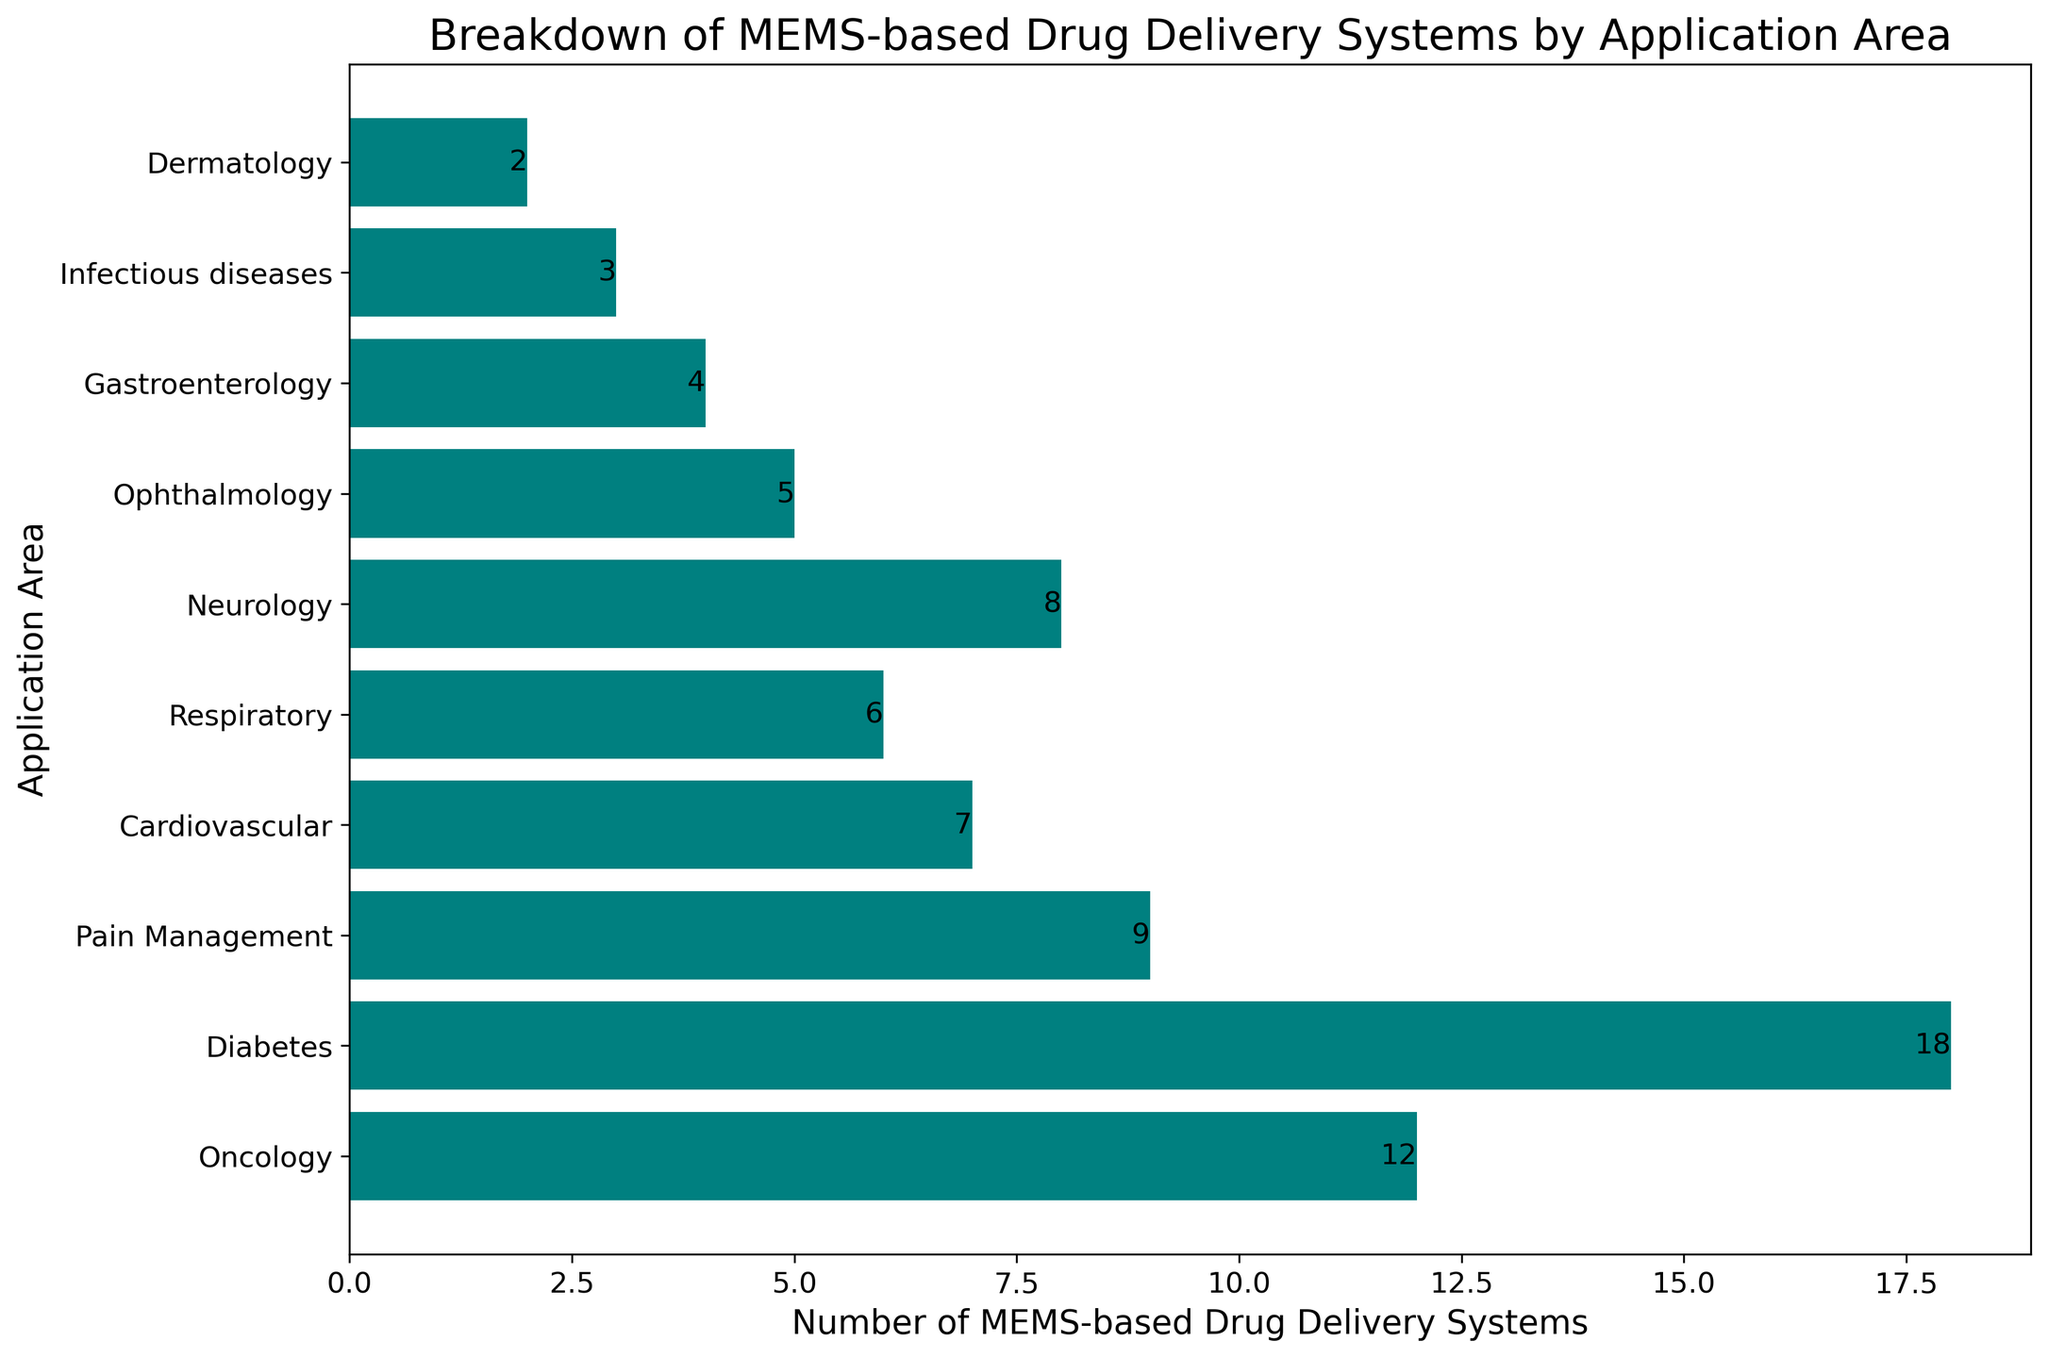What is the total number of MEMS-based drug delivery systems across all application areas? Sum all values: (12 + 18 + 9 + 7 + 6 + 8 + 5 + 4 + 3 + 2) = 74
Answer: 74 Which application area has the highest number of MEMS-based drug delivery systems? Compare the numbers for each area: Diabetes (18) is the highest
Answer: Diabetes How many more MEMS-based drug delivery systems are there in Oncology compared to Gastroenterology? Subtract the number for Gastroenterology from Oncology: 12 - 4 = 8
Answer: 8 What's the average number of MEMS-based drug delivery systems across all application areas? Total is 74, and there are 10 areas: 74 / 10 = 7.4
Answer: 7.4 Which application areas have fewer than 5 MEMS-based drug delivery systems? Identify areas with numbers < 5: Gastroenterology (4), Infectious diseases (3), Dermatology (2)
Answer: Gastroenterology, Infectious diseases, Dermatology What is the sum of MEMS-based drug delivery systems in Diabetes and Neurology? Add the numbers for Diabetes and Neurology: 18 + 8 = 26
Answer: 26 How many application areas have MEMS-based drug delivery systems greater than or equal to 10? Identify areas with numbers >= 10: Diabetes (18), Oncology (12)
Answer: 2 Which application area has the shortest bar in the chart? The application area with the smallest number: Dermatology (2)
Answer: Dermatology How does the number of systems in Respiratory compare to Cardiovascular? Compare the numbers: Cardiovascular (7) is greater than Respiratory (6)
Answer: Cardiovascular has more If you combine the numbers for Pain Management and Respiratory, what would be their combined total? Add the numbers for Pain Management and Respiratory: 9 + 6 = 15
Answer: 15 